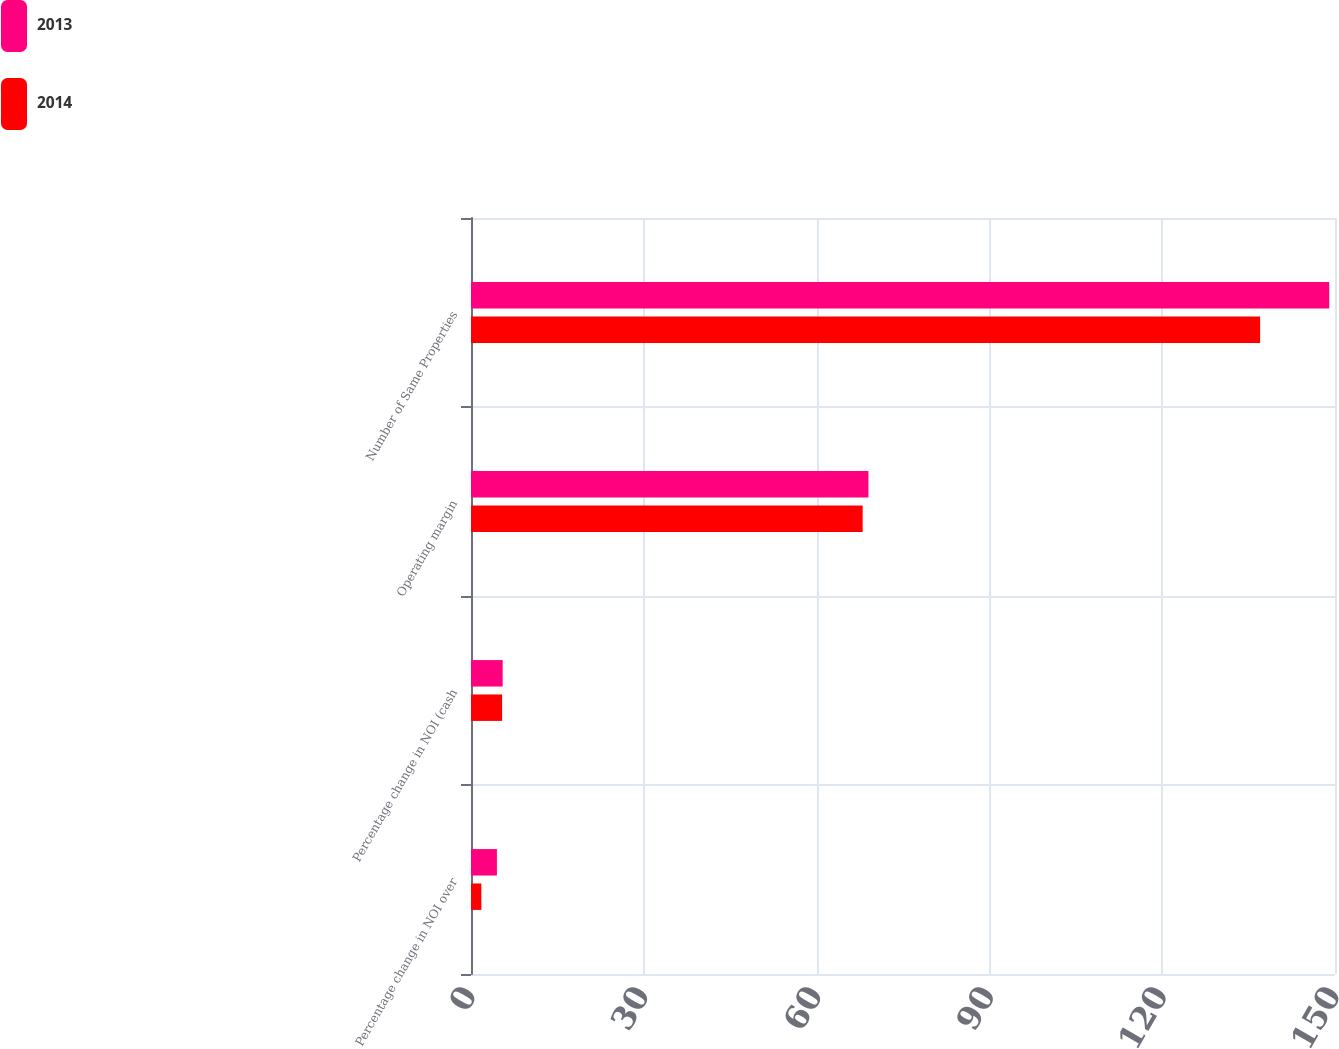Convert chart. <chart><loc_0><loc_0><loc_500><loc_500><stacked_bar_chart><ecel><fcel>Percentage change in NOI over<fcel>Percentage change in NOI (cash<fcel>Operating margin<fcel>Number of Same Properties<nl><fcel>2013<fcel>4.5<fcel>5.5<fcel>69<fcel>149<nl><fcel>2014<fcel>1.8<fcel>5.4<fcel>68<fcel>137<nl></chart> 